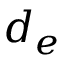<formula> <loc_0><loc_0><loc_500><loc_500>d _ { e }</formula> 